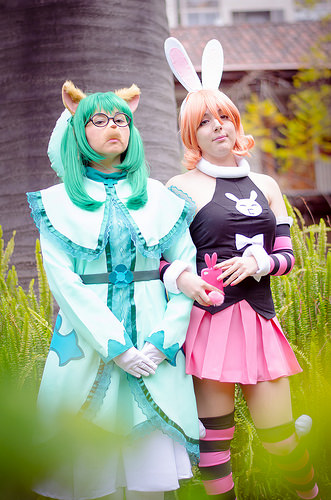<image>
Is there a green girl to the right of the pink girl? No. The green girl is not to the right of the pink girl. The horizontal positioning shows a different relationship. Where is the bunny ears in relation to the girl? Is it on the girl? No. The bunny ears is not positioned on the girl. They may be near each other, but the bunny ears is not supported by or resting on top of the girl. Is there a girl on the girl? No. The girl is not positioned on the girl. They may be near each other, but the girl is not supported by or resting on top of the girl. Is there a bunny ears above the phone case? Yes. The bunny ears is positioned above the phone case in the vertical space, higher up in the scene. 